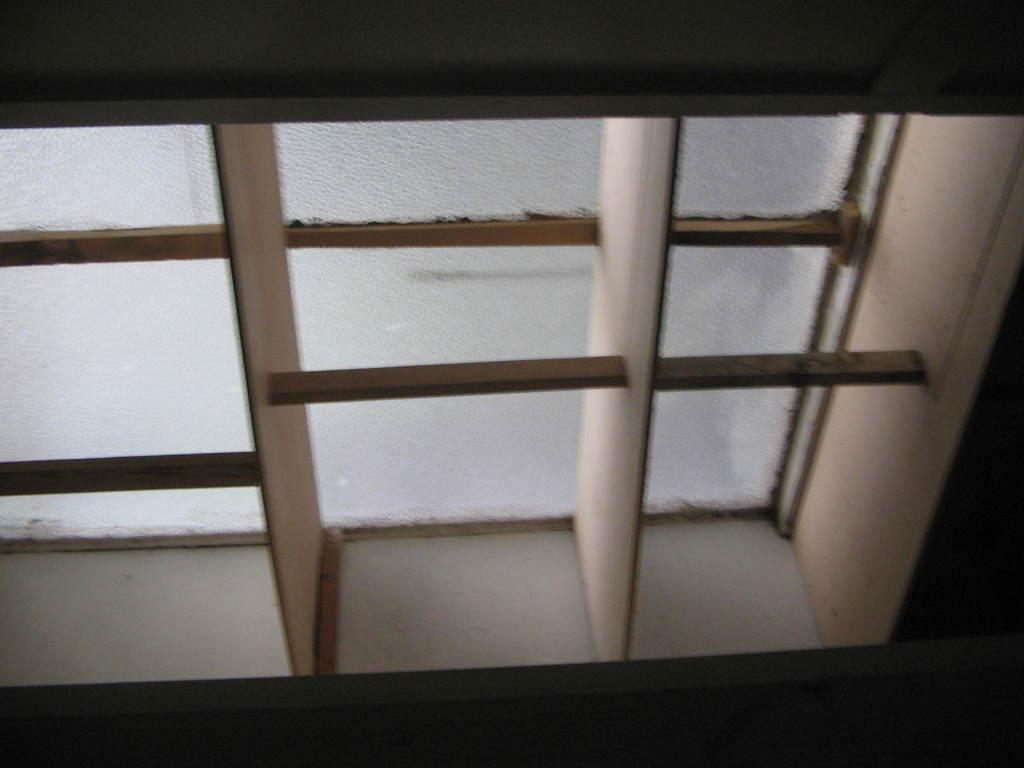Could you give a brief overview of what you see in this image? In this image, I can see a glass window with iron grilles. 